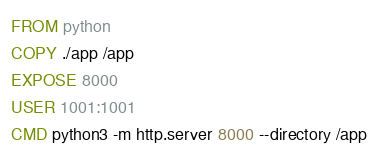Convert code to text. <code><loc_0><loc_0><loc_500><loc_500><_Dockerfile_>FROM python
COPY ./app /app
EXPOSE 8000
USER 1001:1001
CMD python3 -m http.server 8000 --directory /app
</code> 